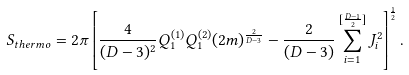Convert formula to latex. <formula><loc_0><loc_0><loc_500><loc_500>S _ { t h e r m o } = 2 \pi \left [ { \frac { 4 } { ( D - 3 ) ^ { 2 } } } Q _ { 1 } ^ { ( 1 ) } Q _ { 1 } ^ { ( 2 ) } ( 2 m ) ^ { \frac { 2 } { D - 3 } } - { \frac { 2 } { ( D - 3 ) } } \sum _ { i = 1 } ^ { [ { \frac { D - 1 } { 2 } } ] } J _ { i } ^ { 2 } \right ] ^ { \frac { 1 } { 2 } } .</formula> 